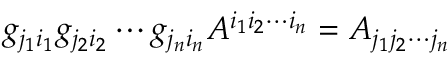<formula> <loc_0><loc_0><loc_500><loc_500>g _ { j _ { 1 } i _ { 1 } } g _ { j _ { 2 } i _ { 2 } } \cdots g _ { j _ { n } i _ { n } } A ^ { i _ { 1 } i _ { 2 } \cdots i _ { n } } = A _ { j _ { 1 } j _ { 2 } \cdots j _ { n } }</formula> 